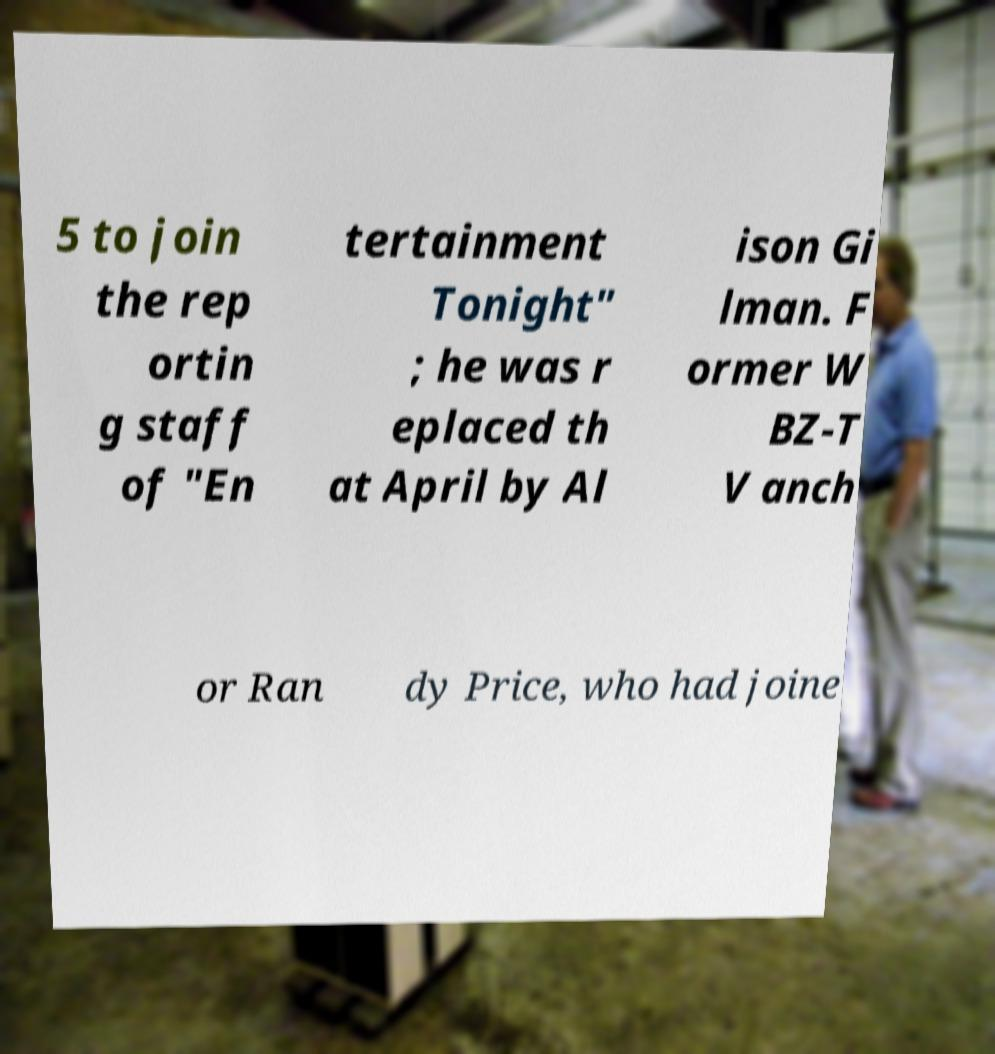Can you accurately transcribe the text from the provided image for me? 5 to join the rep ortin g staff of "En tertainment Tonight" ; he was r eplaced th at April by Al ison Gi lman. F ormer W BZ-T V anch or Ran dy Price, who had joine 